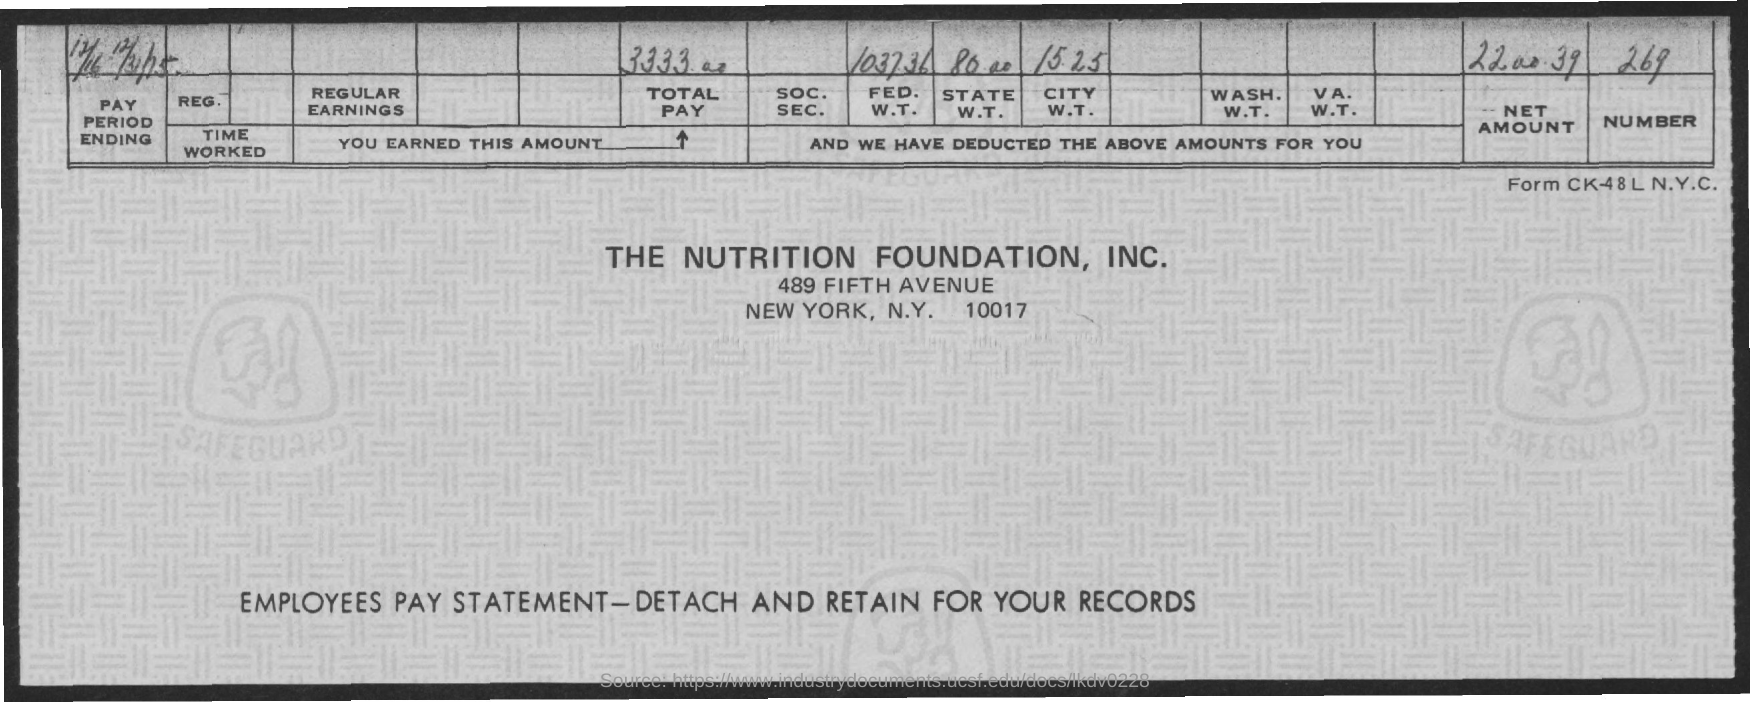Write the amount of "TOTAL PAY"?
Provide a succinct answer. 3333.00. Mention the "NUMBER" provided?
Keep it short and to the point. 269. What is "NET AMOUNT" provided?
Offer a terse response. 2200.39. Mention the FOUNDATION name provided?
Give a very brief answer. THE NUTRITION FOUNDATION, INC. In which city is "THE NUTRITION FOUNDATION, INC." located?
Keep it short and to the point. NEW YORK. Mention the "FED.W.T." amount deducted?
Make the answer very short. 1037.36. Mention the "STATE W.T." amount deducted?
Provide a succinct answer. 80.00. What type of document is this?
Provide a succinct answer. EMPLOYEES PAY STATEMENT. Mention the "CITY W.T." amount deducted?
Your answer should be compact. 15.25. 